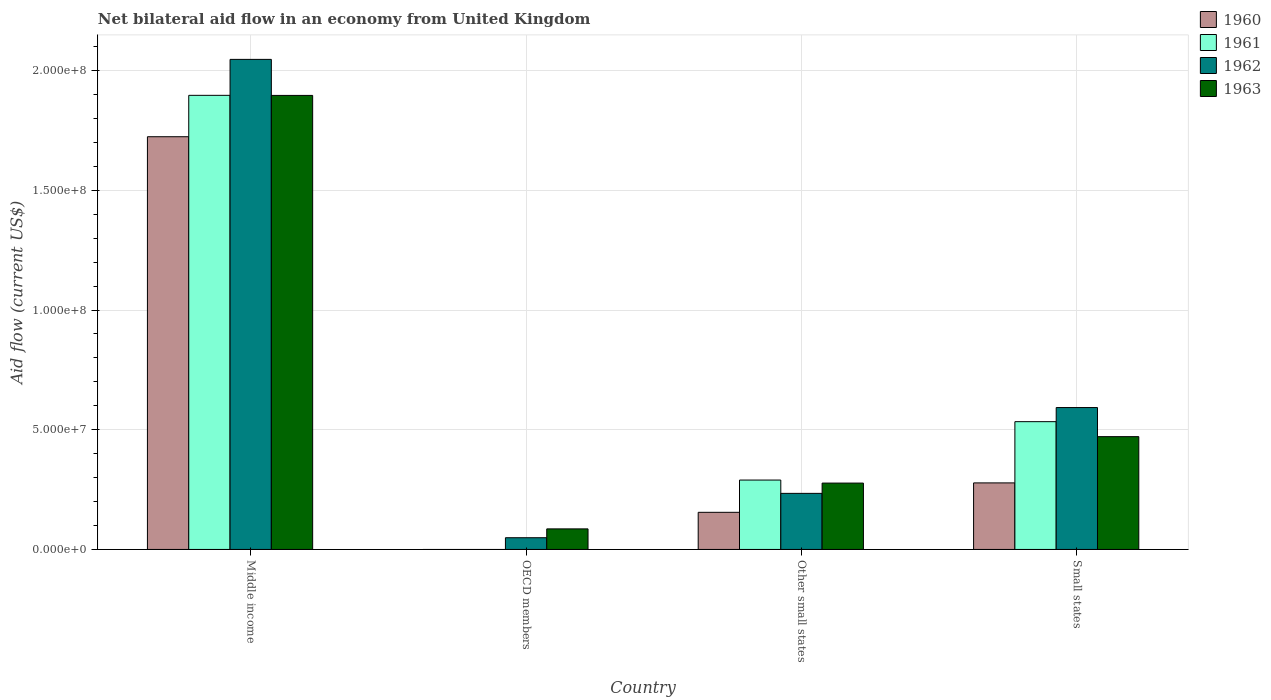How many different coloured bars are there?
Provide a succinct answer. 4. Are the number of bars per tick equal to the number of legend labels?
Your answer should be very brief. No. How many bars are there on the 2nd tick from the left?
Provide a succinct answer. 2. How many bars are there on the 1st tick from the right?
Your response must be concise. 4. What is the label of the 4th group of bars from the left?
Your response must be concise. Small states. What is the net bilateral aid flow in 1963 in Middle income?
Offer a terse response. 1.90e+08. Across all countries, what is the maximum net bilateral aid flow in 1960?
Your response must be concise. 1.72e+08. Across all countries, what is the minimum net bilateral aid flow in 1960?
Your answer should be compact. 0. In which country was the net bilateral aid flow in 1960 maximum?
Provide a succinct answer. Middle income. What is the total net bilateral aid flow in 1961 in the graph?
Provide a succinct answer. 2.72e+08. What is the difference between the net bilateral aid flow in 1962 in OECD members and that in Small states?
Your answer should be very brief. -5.44e+07. What is the difference between the net bilateral aid flow in 1962 in Other small states and the net bilateral aid flow in 1961 in OECD members?
Your answer should be very brief. 2.34e+07. What is the average net bilateral aid flow in 1963 per country?
Offer a very short reply. 6.83e+07. What is the difference between the net bilateral aid flow of/in 1963 and net bilateral aid flow of/in 1962 in Middle income?
Offer a very short reply. -1.50e+07. In how many countries, is the net bilateral aid flow in 1961 greater than 170000000 US$?
Offer a terse response. 1. What is the ratio of the net bilateral aid flow in 1963 in Middle income to that in OECD members?
Provide a short and direct response. 22.08. What is the difference between the highest and the second highest net bilateral aid flow in 1961?
Your response must be concise. 1.61e+08. What is the difference between the highest and the lowest net bilateral aid flow in 1963?
Keep it short and to the point. 1.81e+08. In how many countries, is the net bilateral aid flow in 1961 greater than the average net bilateral aid flow in 1961 taken over all countries?
Make the answer very short. 1. Is it the case that in every country, the sum of the net bilateral aid flow in 1962 and net bilateral aid flow in 1961 is greater than the sum of net bilateral aid flow in 1963 and net bilateral aid flow in 1960?
Your answer should be very brief. No. What is the difference between two consecutive major ticks on the Y-axis?
Your response must be concise. 5.00e+07. Are the values on the major ticks of Y-axis written in scientific E-notation?
Offer a very short reply. Yes. Does the graph contain any zero values?
Offer a very short reply. Yes. Does the graph contain grids?
Your answer should be very brief. Yes. Where does the legend appear in the graph?
Ensure brevity in your answer.  Top right. How are the legend labels stacked?
Provide a short and direct response. Vertical. What is the title of the graph?
Make the answer very short. Net bilateral aid flow in an economy from United Kingdom. Does "2006" appear as one of the legend labels in the graph?
Provide a succinct answer. No. What is the label or title of the X-axis?
Give a very brief answer. Country. What is the label or title of the Y-axis?
Keep it short and to the point. Aid flow (current US$). What is the Aid flow (current US$) in 1960 in Middle income?
Your response must be concise. 1.72e+08. What is the Aid flow (current US$) in 1961 in Middle income?
Your answer should be compact. 1.90e+08. What is the Aid flow (current US$) of 1962 in Middle income?
Ensure brevity in your answer.  2.05e+08. What is the Aid flow (current US$) in 1963 in Middle income?
Your answer should be very brief. 1.90e+08. What is the Aid flow (current US$) in 1960 in OECD members?
Provide a succinct answer. 0. What is the Aid flow (current US$) of 1962 in OECD members?
Offer a very short reply. 4.90e+06. What is the Aid flow (current US$) of 1963 in OECD members?
Your answer should be very brief. 8.59e+06. What is the Aid flow (current US$) in 1960 in Other small states?
Ensure brevity in your answer.  1.55e+07. What is the Aid flow (current US$) of 1961 in Other small states?
Your response must be concise. 2.90e+07. What is the Aid flow (current US$) of 1962 in Other small states?
Your answer should be compact. 2.34e+07. What is the Aid flow (current US$) in 1963 in Other small states?
Keep it short and to the point. 2.77e+07. What is the Aid flow (current US$) in 1960 in Small states?
Keep it short and to the point. 2.78e+07. What is the Aid flow (current US$) in 1961 in Small states?
Keep it short and to the point. 5.34e+07. What is the Aid flow (current US$) in 1962 in Small states?
Make the answer very short. 5.93e+07. What is the Aid flow (current US$) of 1963 in Small states?
Ensure brevity in your answer.  4.71e+07. Across all countries, what is the maximum Aid flow (current US$) of 1960?
Provide a succinct answer. 1.72e+08. Across all countries, what is the maximum Aid flow (current US$) of 1961?
Provide a short and direct response. 1.90e+08. Across all countries, what is the maximum Aid flow (current US$) in 1962?
Provide a succinct answer. 2.05e+08. Across all countries, what is the maximum Aid flow (current US$) of 1963?
Your response must be concise. 1.90e+08. Across all countries, what is the minimum Aid flow (current US$) in 1960?
Ensure brevity in your answer.  0. Across all countries, what is the minimum Aid flow (current US$) in 1962?
Make the answer very short. 4.90e+06. Across all countries, what is the minimum Aid flow (current US$) of 1963?
Ensure brevity in your answer.  8.59e+06. What is the total Aid flow (current US$) of 1960 in the graph?
Your answer should be very brief. 2.16e+08. What is the total Aid flow (current US$) in 1961 in the graph?
Offer a terse response. 2.72e+08. What is the total Aid flow (current US$) of 1962 in the graph?
Make the answer very short. 2.92e+08. What is the total Aid flow (current US$) in 1963 in the graph?
Give a very brief answer. 2.73e+08. What is the difference between the Aid flow (current US$) of 1962 in Middle income and that in OECD members?
Offer a terse response. 2.00e+08. What is the difference between the Aid flow (current US$) in 1963 in Middle income and that in OECD members?
Your response must be concise. 1.81e+08. What is the difference between the Aid flow (current US$) of 1960 in Middle income and that in Other small states?
Your answer should be very brief. 1.57e+08. What is the difference between the Aid flow (current US$) in 1961 in Middle income and that in Other small states?
Ensure brevity in your answer.  1.61e+08. What is the difference between the Aid flow (current US$) in 1962 in Middle income and that in Other small states?
Provide a short and direct response. 1.81e+08. What is the difference between the Aid flow (current US$) in 1963 in Middle income and that in Other small states?
Your response must be concise. 1.62e+08. What is the difference between the Aid flow (current US$) in 1960 in Middle income and that in Small states?
Ensure brevity in your answer.  1.45e+08. What is the difference between the Aid flow (current US$) in 1961 in Middle income and that in Small states?
Keep it short and to the point. 1.36e+08. What is the difference between the Aid flow (current US$) of 1962 in Middle income and that in Small states?
Your answer should be very brief. 1.45e+08. What is the difference between the Aid flow (current US$) of 1963 in Middle income and that in Small states?
Offer a very short reply. 1.43e+08. What is the difference between the Aid flow (current US$) in 1962 in OECD members and that in Other small states?
Make the answer very short. -1.85e+07. What is the difference between the Aid flow (current US$) of 1963 in OECD members and that in Other small states?
Keep it short and to the point. -1.91e+07. What is the difference between the Aid flow (current US$) of 1962 in OECD members and that in Small states?
Ensure brevity in your answer.  -5.44e+07. What is the difference between the Aid flow (current US$) in 1963 in OECD members and that in Small states?
Make the answer very short. -3.85e+07. What is the difference between the Aid flow (current US$) of 1960 in Other small states and that in Small states?
Make the answer very short. -1.23e+07. What is the difference between the Aid flow (current US$) in 1961 in Other small states and that in Small states?
Offer a terse response. -2.44e+07. What is the difference between the Aid flow (current US$) in 1962 in Other small states and that in Small states?
Offer a terse response. -3.58e+07. What is the difference between the Aid flow (current US$) of 1963 in Other small states and that in Small states?
Make the answer very short. -1.94e+07. What is the difference between the Aid flow (current US$) of 1960 in Middle income and the Aid flow (current US$) of 1962 in OECD members?
Your response must be concise. 1.68e+08. What is the difference between the Aid flow (current US$) of 1960 in Middle income and the Aid flow (current US$) of 1963 in OECD members?
Offer a very short reply. 1.64e+08. What is the difference between the Aid flow (current US$) in 1961 in Middle income and the Aid flow (current US$) in 1962 in OECD members?
Your answer should be very brief. 1.85e+08. What is the difference between the Aid flow (current US$) of 1961 in Middle income and the Aid flow (current US$) of 1963 in OECD members?
Your answer should be very brief. 1.81e+08. What is the difference between the Aid flow (current US$) in 1962 in Middle income and the Aid flow (current US$) in 1963 in OECD members?
Your answer should be very brief. 1.96e+08. What is the difference between the Aid flow (current US$) in 1960 in Middle income and the Aid flow (current US$) in 1961 in Other small states?
Provide a short and direct response. 1.43e+08. What is the difference between the Aid flow (current US$) in 1960 in Middle income and the Aid flow (current US$) in 1962 in Other small states?
Your answer should be very brief. 1.49e+08. What is the difference between the Aid flow (current US$) of 1960 in Middle income and the Aid flow (current US$) of 1963 in Other small states?
Make the answer very short. 1.45e+08. What is the difference between the Aid flow (current US$) in 1961 in Middle income and the Aid flow (current US$) in 1962 in Other small states?
Offer a terse response. 1.66e+08. What is the difference between the Aid flow (current US$) of 1961 in Middle income and the Aid flow (current US$) of 1963 in Other small states?
Provide a succinct answer. 1.62e+08. What is the difference between the Aid flow (current US$) of 1962 in Middle income and the Aid flow (current US$) of 1963 in Other small states?
Your answer should be very brief. 1.77e+08. What is the difference between the Aid flow (current US$) of 1960 in Middle income and the Aid flow (current US$) of 1961 in Small states?
Ensure brevity in your answer.  1.19e+08. What is the difference between the Aid flow (current US$) of 1960 in Middle income and the Aid flow (current US$) of 1962 in Small states?
Your answer should be very brief. 1.13e+08. What is the difference between the Aid flow (current US$) of 1960 in Middle income and the Aid flow (current US$) of 1963 in Small states?
Keep it short and to the point. 1.25e+08. What is the difference between the Aid flow (current US$) of 1961 in Middle income and the Aid flow (current US$) of 1962 in Small states?
Your answer should be compact. 1.30e+08. What is the difference between the Aid flow (current US$) in 1961 in Middle income and the Aid flow (current US$) in 1963 in Small states?
Provide a short and direct response. 1.43e+08. What is the difference between the Aid flow (current US$) in 1962 in Middle income and the Aid flow (current US$) in 1963 in Small states?
Provide a succinct answer. 1.58e+08. What is the difference between the Aid flow (current US$) in 1962 in OECD members and the Aid flow (current US$) in 1963 in Other small states?
Your answer should be very brief. -2.28e+07. What is the difference between the Aid flow (current US$) in 1962 in OECD members and the Aid flow (current US$) in 1963 in Small states?
Keep it short and to the point. -4.22e+07. What is the difference between the Aid flow (current US$) in 1960 in Other small states and the Aid flow (current US$) in 1961 in Small states?
Ensure brevity in your answer.  -3.79e+07. What is the difference between the Aid flow (current US$) of 1960 in Other small states and the Aid flow (current US$) of 1962 in Small states?
Provide a short and direct response. -4.38e+07. What is the difference between the Aid flow (current US$) in 1960 in Other small states and the Aid flow (current US$) in 1963 in Small states?
Keep it short and to the point. -3.16e+07. What is the difference between the Aid flow (current US$) in 1961 in Other small states and the Aid flow (current US$) in 1962 in Small states?
Offer a terse response. -3.03e+07. What is the difference between the Aid flow (current US$) of 1961 in Other small states and the Aid flow (current US$) of 1963 in Small states?
Provide a short and direct response. -1.81e+07. What is the difference between the Aid flow (current US$) of 1962 in Other small states and the Aid flow (current US$) of 1963 in Small states?
Your response must be concise. -2.37e+07. What is the average Aid flow (current US$) in 1960 per country?
Your answer should be very brief. 5.39e+07. What is the average Aid flow (current US$) in 1961 per country?
Offer a terse response. 6.80e+07. What is the average Aid flow (current US$) of 1962 per country?
Your answer should be compact. 7.31e+07. What is the average Aid flow (current US$) in 1963 per country?
Your answer should be very brief. 6.83e+07. What is the difference between the Aid flow (current US$) of 1960 and Aid flow (current US$) of 1961 in Middle income?
Make the answer very short. -1.73e+07. What is the difference between the Aid flow (current US$) in 1960 and Aid flow (current US$) in 1962 in Middle income?
Ensure brevity in your answer.  -3.23e+07. What is the difference between the Aid flow (current US$) of 1960 and Aid flow (current US$) of 1963 in Middle income?
Provide a succinct answer. -1.73e+07. What is the difference between the Aid flow (current US$) of 1961 and Aid flow (current US$) of 1962 in Middle income?
Offer a terse response. -1.50e+07. What is the difference between the Aid flow (current US$) of 1962 and Aid flow (current US$) of 1963 in Middle income?
Your response must be concise. 1.50e+07. What is the difference between the Aid flow (current US$) in 1962 and Aid flow (current US$) in 1963 in OECD members?
Your response must be concise. -3.69e+06. What is the difference between the Aid flow (current US$) in 1960 and Aid flow (current US$) in 1961 in Other small states?
Your response must be concise. -1.35e+07. What is the difference between the Aid flow (current US$) in 1960 and Aid flow (current US$) in 1962 in Other small states?
Provide a short and direct response. -7.92e+06. What is the difference between the Aid flow (current US$) in 1960 and Aid flow (current US$) in 1963 in Other small states?
Keep it short and to the point. -1.22e+07. What is the difference between the Aid flow (current US$) in 1961 and Aid flow (current US$) in 1962 in Other small states?
Your answer should be very brief. 5.56e+06. What is the difference between the Aid flow (current US$) of 1961 and Aid flow (current US$) of 1963 in Other small states?
Give a very brief answer. 1.27e+06. What is the difference between the Aid flow (current US$) of 1962 and Aid flow (current US$) of 1963 in Other small states?
Your answer should be compact. -4.29e+06. What is the difference between the Aid flow (current US$) of 1960 and Aid flow (current US$) of 1961 in Small states?
Offer a very short reply. -2.56e+07. What is the difference between the Aid flow (current US$) of 1960 and Aid flow (current US$) of 1962 in Small states?
Provide a succinct answer. -3.15e+07. What is the difference between the Aid flow (current US$) of 1960 and Aid flow (current US$) of 1963 in Small states?
Provide a short and direct response. -1.93e+07. What is the difference between the Aid flow (current US$) of 1961 and Aid flow (current US$) of 1962 in Small states?
Keep it short and to the point. -5.89e+06. What is the difference between the Aid flow (current US$) in 1961 and Aid flow (current US$) in 1963 in Small states?
Give a very brief answer. 6.26e+06. What is the difference between the Aid flow (current US$) of 1962 and Aid flow (current US$) of 1963 in Small states?
Offer a terse response. 1.22e+07. What is the ratio of the Aid flow (current US$) of 1962 in Middle income to that in OECD members?
Your answer should be very brief. 41.78. What is the ratio of the Aid flow (current US$) of 1963 in Middle income to that in OECD members?
Keep it short and to the point. 22.08. What is the ratio of the Aid flow (current US$) in 1960 in Middle income to that in Other small states?
Provide a succinct answer. 11.12. What is the ratio of the Aid flow (current US$) in 1961 in Middle income to that in Other small states?
Provide a short and direct response. 6.54. What is the ratio of the Aid flow (current US$) of 1962 in Middle income to that in Other small states?
Provide a short and direct response. 8.74. What is the ratio of the Aid flow (current US$) of 1963 in Middle income to that in Other small states?
Your answer should be very brief. 6.84. What is the ratio of the Aid flow (current US$) of 1960 in Middle income to that in Small states?
Your answer should be compact. 6.2. What is the ratio of the Aid flow (current US$) in 1961 in Middle income to that in Small states?
Your answer should be compact. 3.55. What is the ratio of the Aid flow (current US$) in 1962 in Middle income to that in Small states?
Provide a succinct answer. 3.45. What is the ratio of the Aid flow (current US$) in 1963 in Middle income to that in Small states?
Offer a very short reply. 4.03. What is the ratio of the Aid flow (current US$) in 1962 in OECD members to that in Other small states?
Give a very brief answer. 0.21. What is the ratio of the Aid flow (current US$) in 1963 in OECD members to that in Other small states?
Your answer should be very brief. 0.31. What is the ratio of the Aid flow (current US$) of 1962 in OECD members to that in Small states?
Your response must be concise. 0.08. What is the ratio of the Aid flow (current US$) in 1963 in OECD members to that in Small states?
Offer a very short reply. 0.18. What is the ratio of the Aid flow (current US$) in 1960 in Other small states to that in Small states?
Keep it short and to the point. 0.56. What is the ratio of the Aid flow (current US$) in 1961 in Other small states to that in Small states?
Ensure brevity in your answer.  0.54. What is the ratio of the Aid flow (current US$) in 1962 in Other small states to that in Small states?
Make the answer very short. 0.4. What is the ratio of the Aid flow (current US$) of 1963 in Other small states to that in Small states?
Provide a short and direct response. 0.59. What is the difference between the highest and the second highest Aid flow (current US$) of 1960?
Your response must be concise. 1.45e+08. What is the difference between the highest and the second highest Aid flow (current US$) in 1961?
Give a very brief answer. 1.36e+08. What is the difference between the highest and the second highest Aid flow (current US$) in 1962?
Your answer should be compact. 1.45e+08. What is the difference between the highest and the second highest Aid flow (current US$) in 1963?
Give a very brief answer. 1.43e+08. What is the difference between the highest and the lowest Aid flow (current US$) of 1960?
Offer a terse response. 1.72e+08. What is the difference between the highest and the lowest Aid flow (current US$) in 1961?
Give a very brief answer. 1.90e+08. What is the difference between the highest and the lowest Aid flow (current US$) in 1962?
Ensure brevity in your answer.  2.00e+08. What is the difference between the highest and the lowest Aid flow (current US$) of 1963?
Make the answer very short. 1.81e+08. 